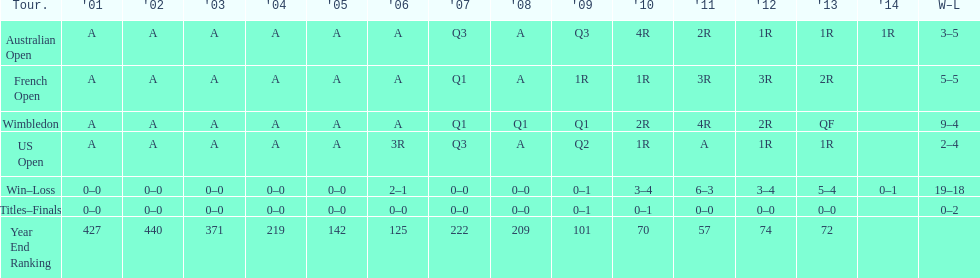What tournament has 5-5 as it's "w-l" record? French Open. 